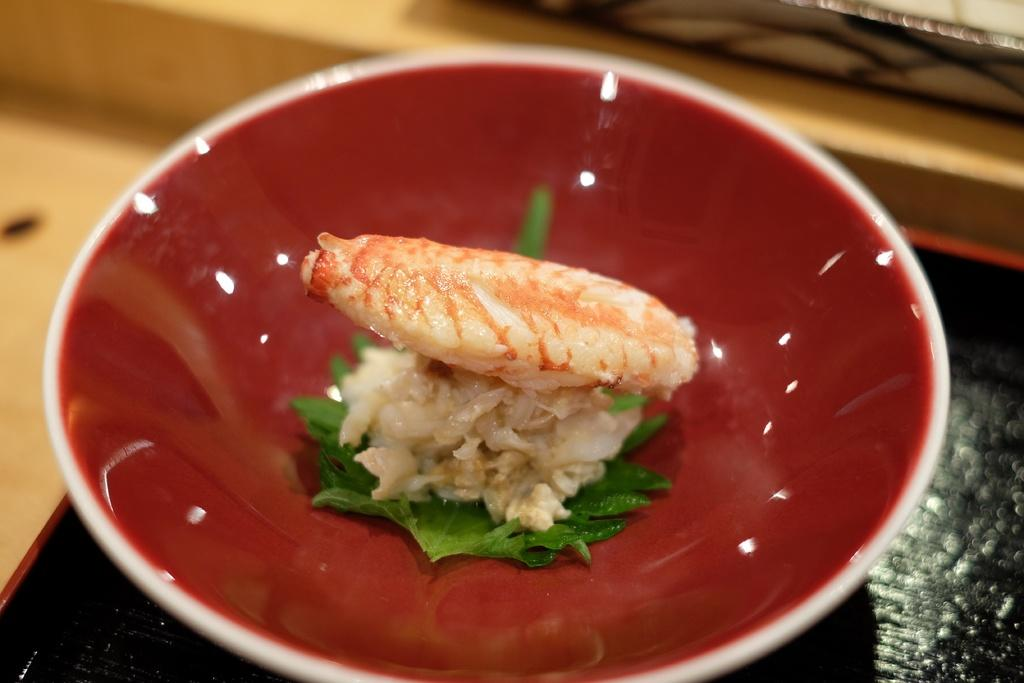What type of food items can be seen in the image? There are food items in the image, but the specific types are not mentioned in the facts. How are the food items arranged in the image? The food items are in a bowl or on a plate, as stated in the facts. What is the bowl or plate placed on in the image? The facts do not specify what the bowl or plate is placed on. Can you describe the background of the image? The background of the image is blurry, as mentioned in the facts. What type of ink is used to write the magic spell on the chance card in the image? There is no mention of magic, chance, or ink in the image, so this question cannot be answered definitively. 